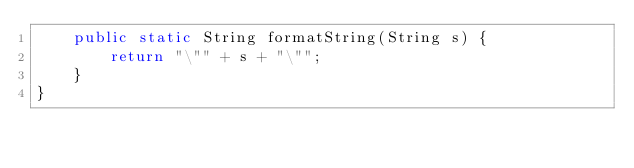<code> <loc_0><loc_0><loc_500><loc_500><_Java_>    public static String formatString(String s) {
        return "\"" + s + "\"";
    }
}
</code> 